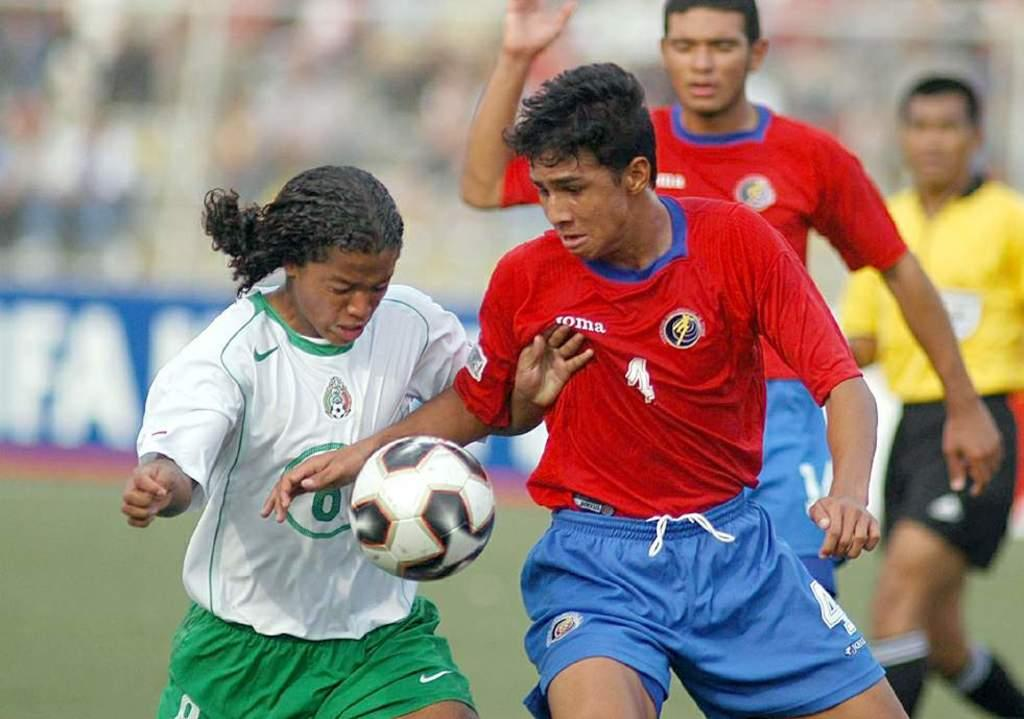Provide a one-sentence caption for the provided image. 2 soccer players fighting for a ball and one of them has a name on his shirt. 